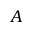Convert formula to latex. <formula><loc_0><loc_0><loc_500><loc_500>A</formula> 